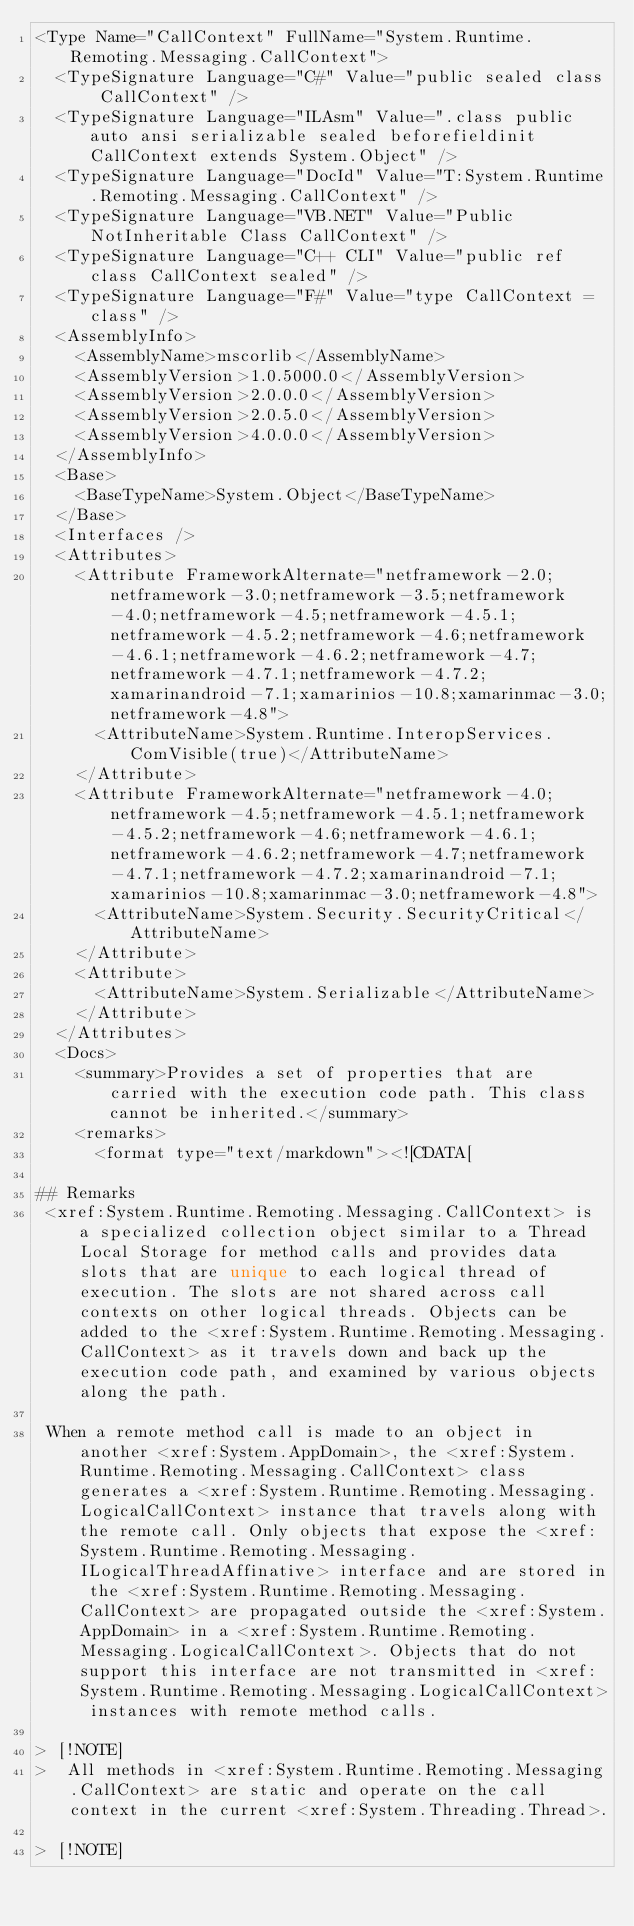<code> <loc_0><loc_0><loc_500><loc_500><_XML_><Type Name="CallContext" FullName="System.Runtime.Remoting.Messaging.CallContext">
  <TypeSignature Language="C#" Value="public sealed class CallContext" />
  <TypeSignature Language="ILAsm" Value=".class public auto ansi serializable sealed beforefieldinit CallContext extends System.Object" />
  <TypeSignature Language="DocId" Value="T:System.Runtime.Remoting.Messaging.CallContext" />
  <TypeSignature Language="VB.NET" Value="Public NotInheritable Class CallContext" />
  <TypeSignature Language="C++ CLI" Value="public ref class CallContext sealed" />
  <TypeSignature Language="F#" Value="type CallContext = class" />
  <AssemblyInfo>
    <AssemblyName>mscorlib</AssemblyName>
    <AssemblyVersion>1.0.5000.0</AssemblyVersion>
    <AssemblyVersion>2.0.0.0</AssemblyVersion>
    <AssemblyVersion>2.0.5.0</AssemblyVersion>
    <AssemblyVersion>4.0.0.0</AssemblyVersion>
  </AssemblyInfo>
  <Base>
    <BaseTypeName>System.Object</BaseTypeName>
  </Base>
  <Interfaces />
  <Attributes>
    <Attribute FrameworkAlternate="netframework-2.0;netframework-3.0;netframework-3.5;netframework-4.0;netframework-4.5;netframework-4.5.1;netframework-4.5.2;netframework-4.6;netframework-4.6.1;netframework-4.6.2;netframework-4.7;netframework-4.7.1;netframework-4.7.2;xamarinandroid-7.1;xamarinios-10.8;xamarinmac-3.0;netframework-4.8">
      <AttributeName>System.Runtime.InteropServices.ComVisible(true)</AttributeName>
    </Attribute>
    <Attribute FrameworkAlternate="netframework-4.0;netframework-4.5;netframework-4.5.1;netframework-4.5.2;netframework-4.6;netframework-4.6.1;netframework-4.6.2;netframework-4.7;netframework-4.7.1;netframework-4.7.2;xamarinandroid-7.1;xamarinios-10.8;xamarinmac-3.0;netframework-4.8">
      <AttributeName>System.Security.SecurityCritical</AttributeName>
    </Attribute>
    <Attribute>
      <AttributeName>System.Serializable</AttributeName>
    </Attribute>
  </Attributes>
  <Docs>
    <summary>Provides a set of properties that are carried with the execution code path. This class cannot be inherited.</summary>
    <remarks>
      <format type="text/markdown"><![CDATA[  
  
## Remarks  
 <xref:System.Runtime.Remoting.Messaging.CallContext> is a specialized collection object similar to a Thread Local Storage for method calls and provides data slots that are unique to each logical thread of execution. The slots are not shared across call contexts on other logical threads. Objects can be added to the <xref:System.Runtime.Remoting.Messaging.CallContext> as it travels down and back up the execution code path, and examined by various objects along the path.  
  
 When a remote method call is made to an object in another <xref:System.AppDomain>, the <xref:System.Runtime.Remoting.Messaging.CallContext> class generates a <xref:System.Runtime.Remoting.Messaging.LogicalCallContext> instance that travels along with the remote call. Only objects that expose the <xref:System.Runtime.Remoting.Messaging.ILogicalThreadAffinative> interface and are stored in the <xref:System.Runtime.Remoting.Messaging.CallContext> are propagated outside the <xref:System.AppDomain> in a <xref:System.Runtime.Remoting.Messaging.LogicalCallContext>. Objects that do not support this interface are not transmitted in <xref:System.Runtime.Remoting.Messaging.LogicalCallContext> instances with remote method calls.  
  
> [!NOTE]
>  All methods in <xref:System.Runtime.Remoting.Messaging.CallContext> are static and operate on the call context in the current <xref:System.Threading.Thread>.  
  
> [!NOTE]</code> 